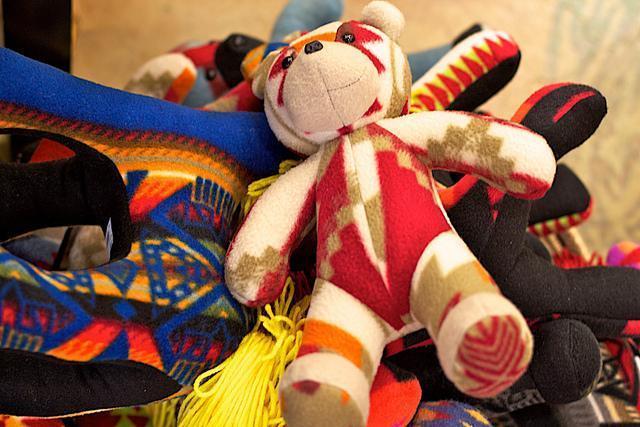How many tires does the truck have?
Give a very brief answer. 0. 